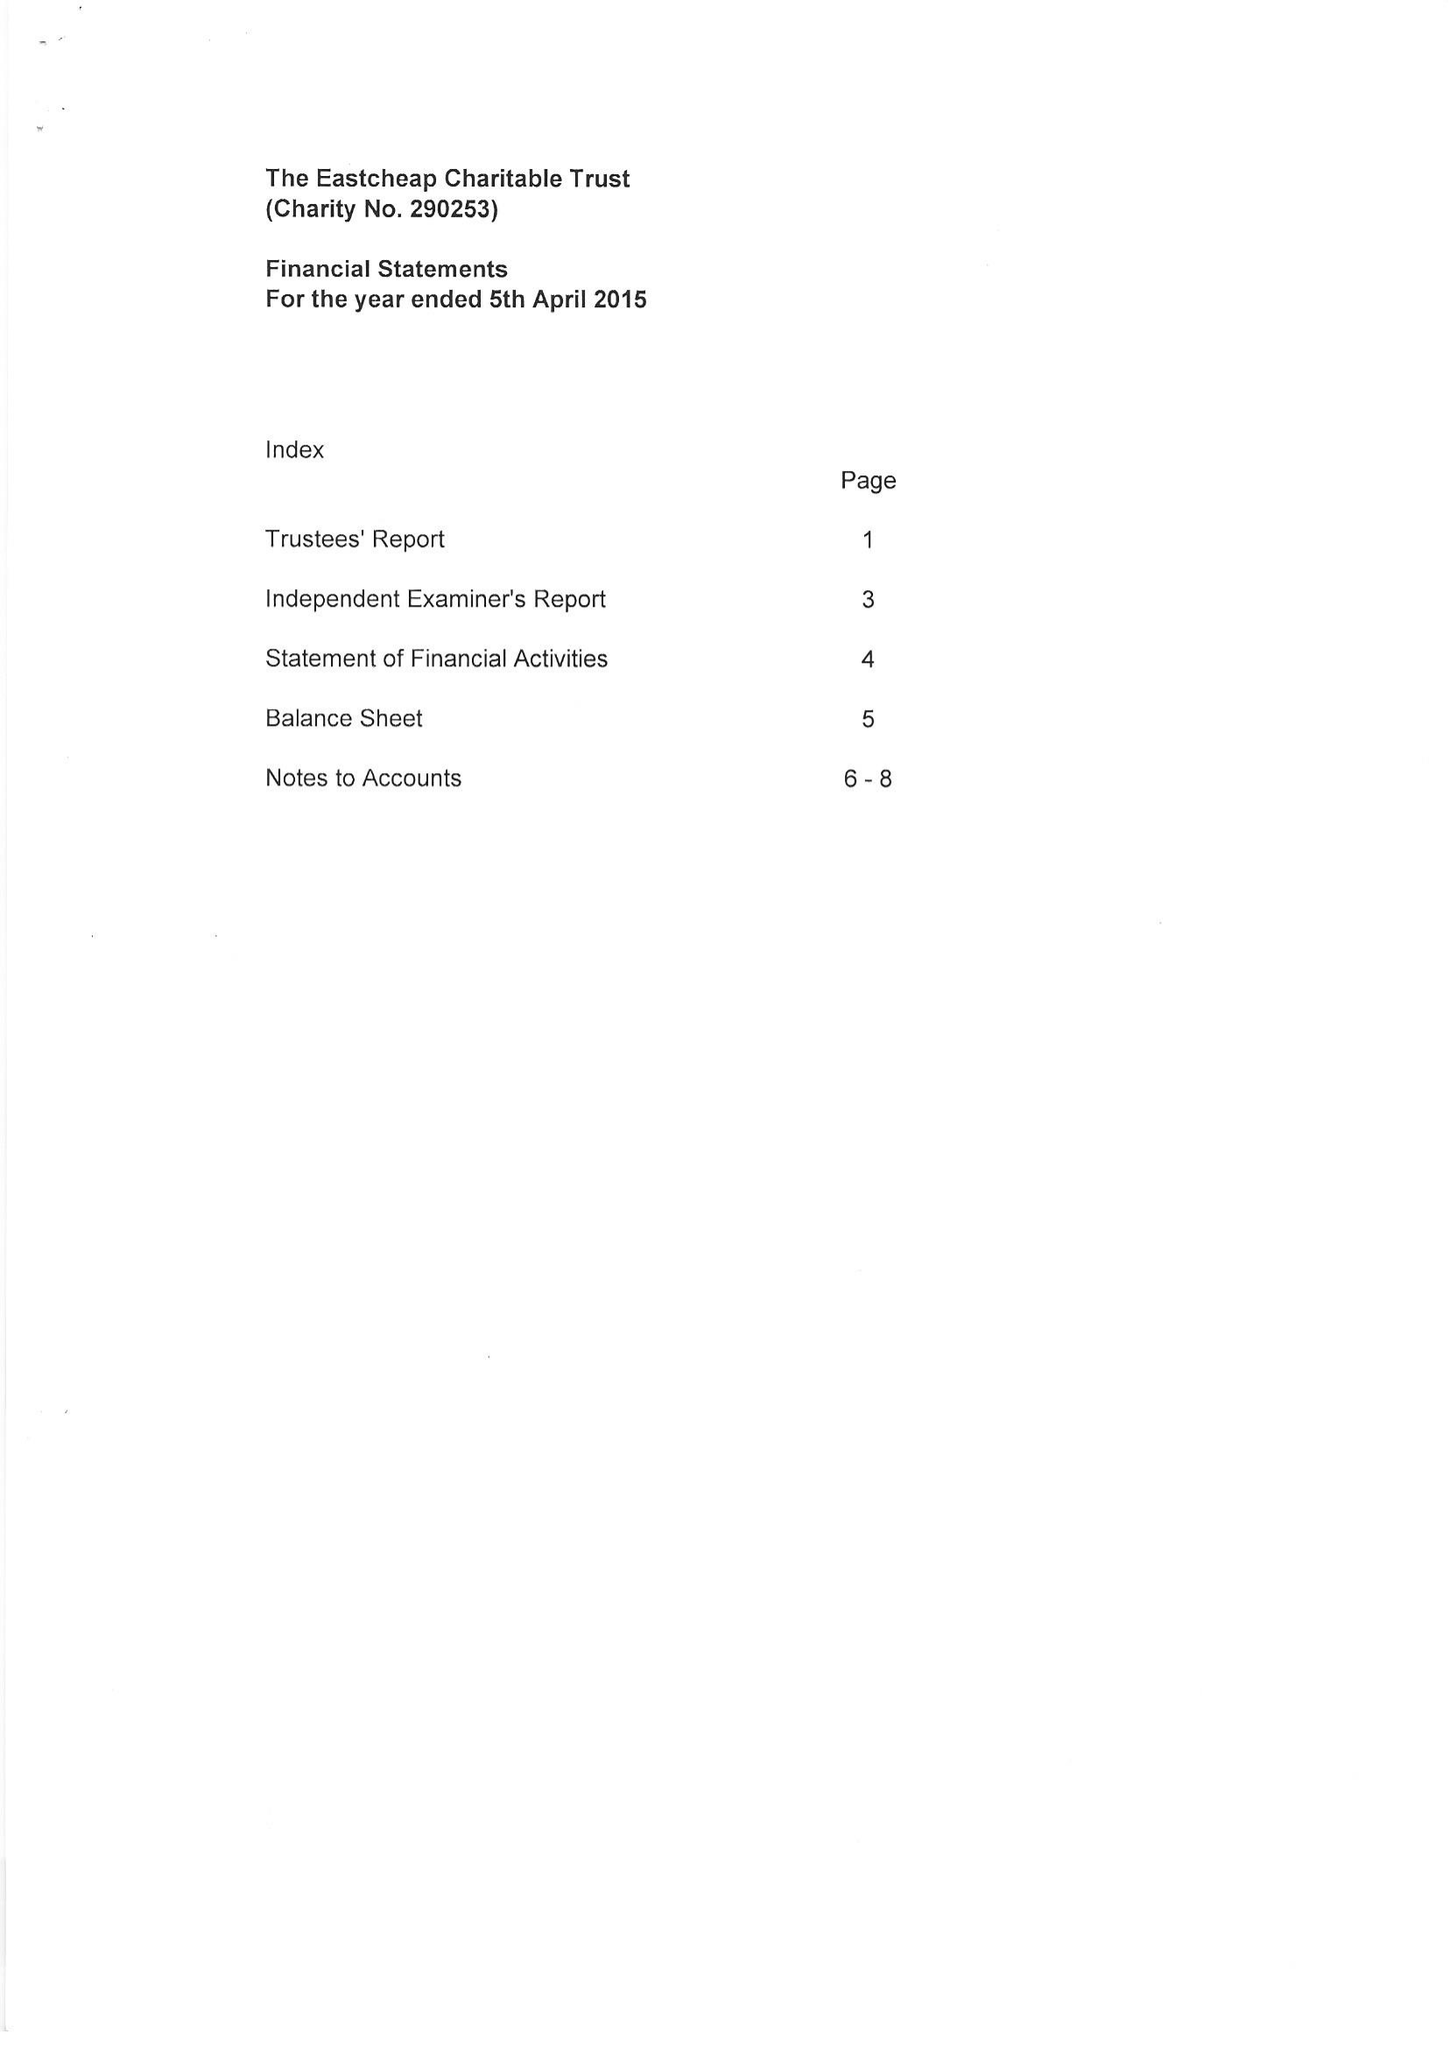What is the value for the address__postcode?
Answer the question using a single word or phrase. GU10 2HL 